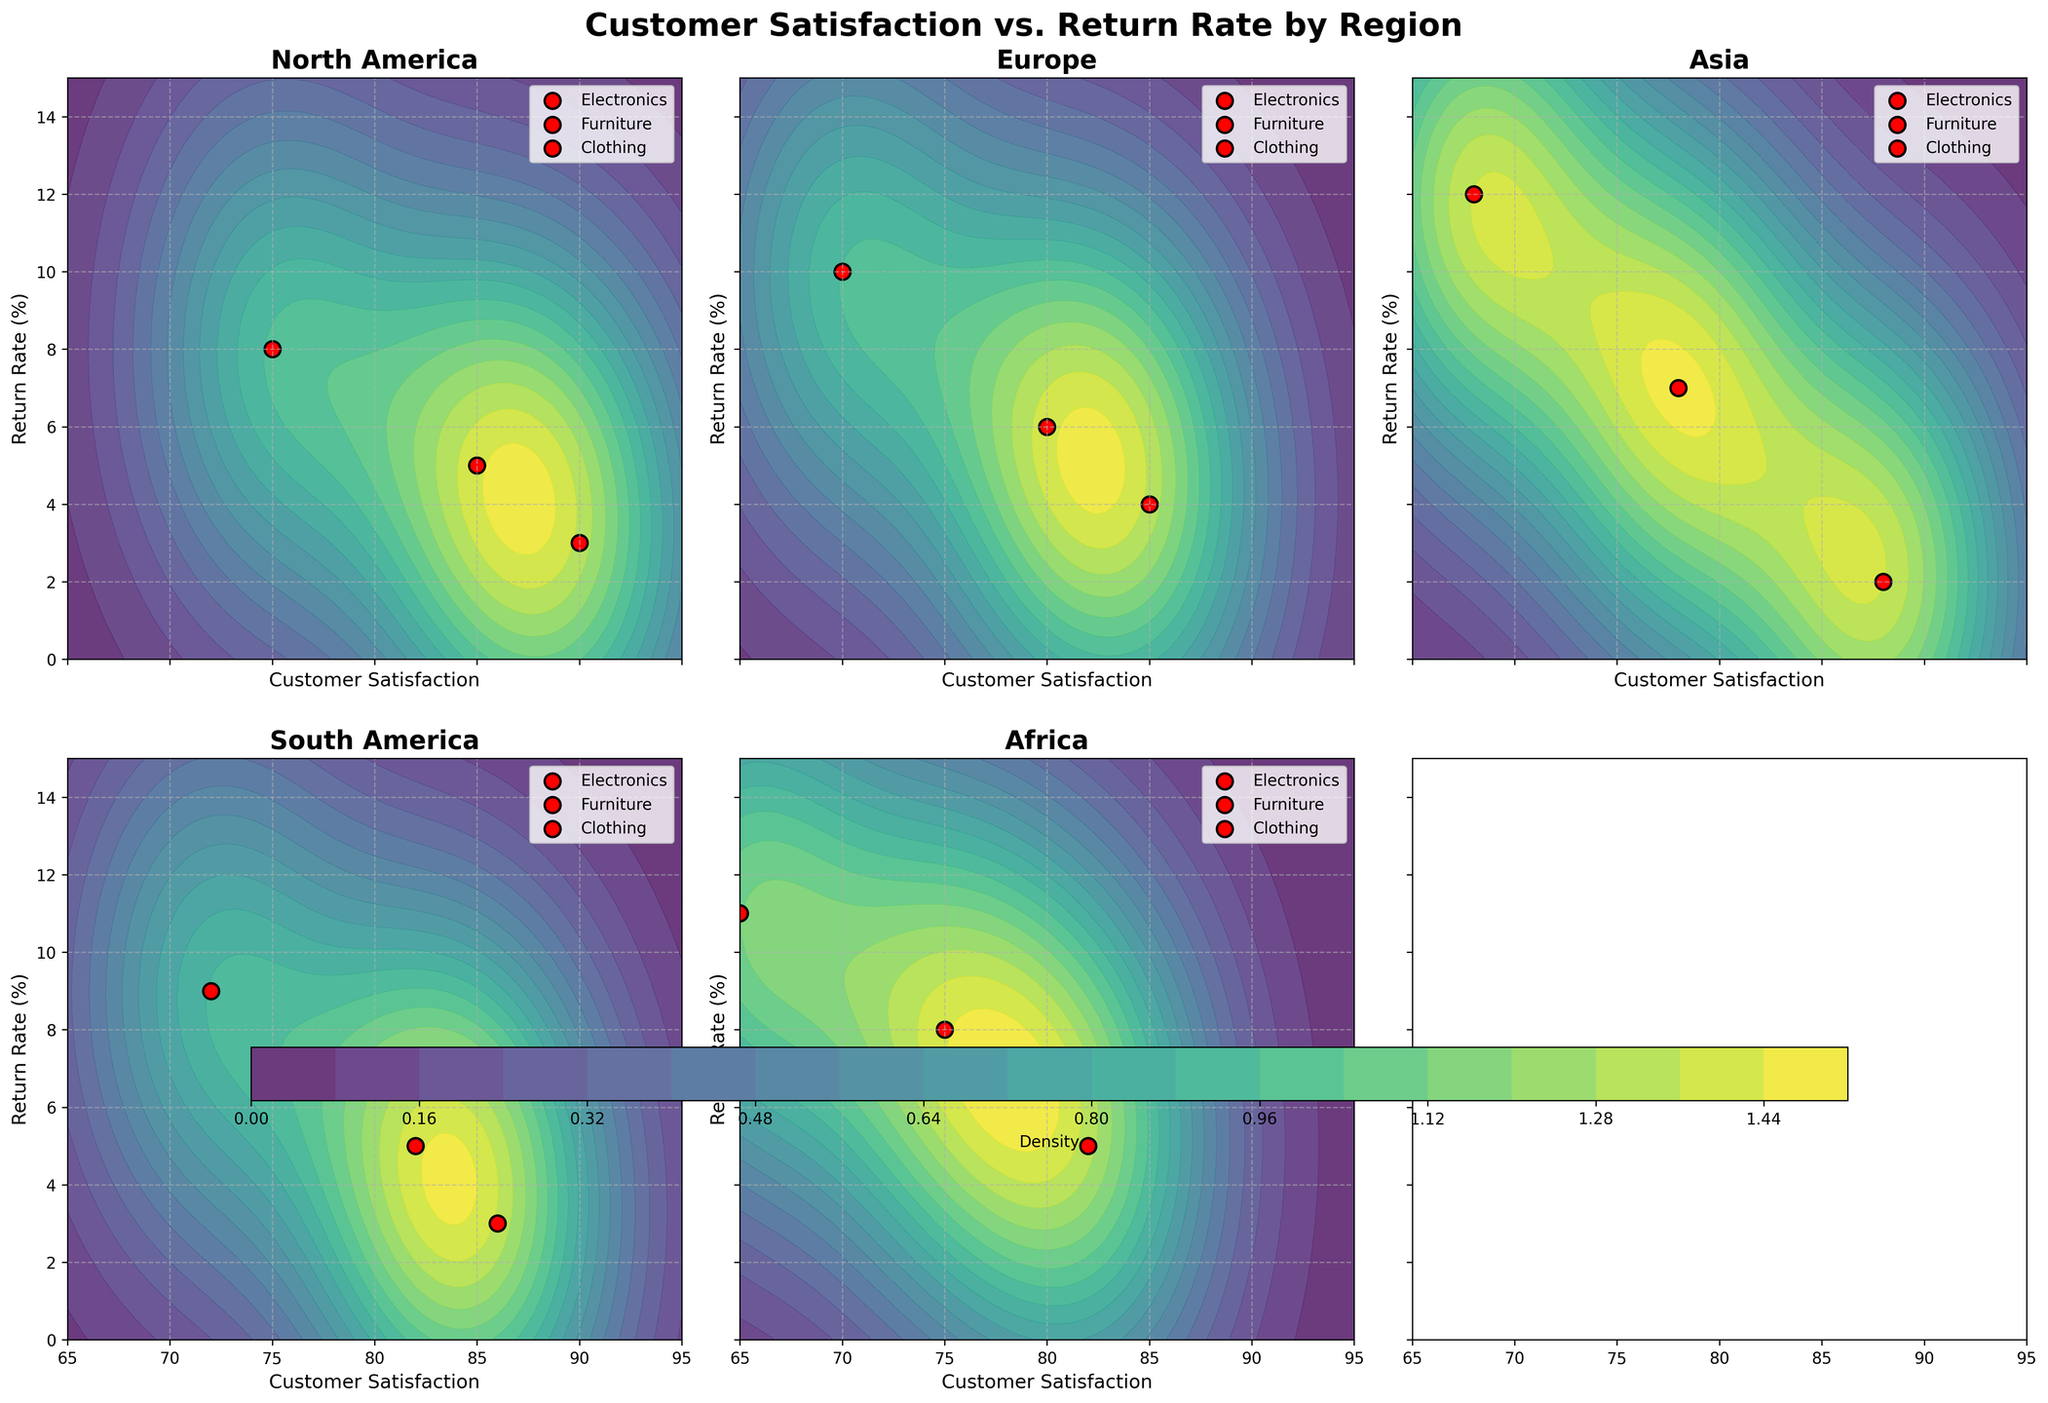What is the title of the figure? The title of the figure is prominently placed at the top of the plot. Based on the data and context provided, it should describe the relationship between Customer Satisfaction and Return Rate across different regions.
Answer: Customer Satisfaction vs. Return Rate by Region How many subplots are there in the figure? The figure is divided into smaller plots for each region. By looking at the number of regions mentioned in the data and the subplot format, you can count the total subplots.
Answer: 6 Which region has the highest customer satisfaction for electronics? Locate the subplot for each region and identify where the point representing electronics is plotted. Compare these satisfaction values across regions.
Answer: North America What is the range of the x-axis in all subplots? Observe the x-axis labels in any of the subplots as they are shared. The min and max values indicate the range of customer satisfaction.
Answer: 65 to 95 Between Europe and Asia, which region has a higher return rate for clothing? In the subplots for Europe and Asia, identify the y-values for the clothing product points and compare the values.
Answer: Asia Which product has the lowest return rate in South America? Look at the subplot for South America and identify the data point with the lowest y-value. Check which product this point represents.
Answer: Furniture In which region does furniture have the highest satisfaction rating? Scan the furniture points across all regional subplots and compare their x-values to find the highest satisfaction rating.
Answer: North America Which two regions have a customer satisfaction rate of around 70 for clothing? Identify the subplots for all regions and check for clothing points that align closely with a satisfaction rating of 70.
Answer: Europe and Asia Is there a region with no product having a return rate above 10%? For each subplot, observe if all the product points have y-values below 10%. Confirm this observation by cross-referencing with multiple subplots.
Answer: South America Which region shows the highest density levels according to the color intensity in the contour plots? Assess the contour plots and compare the intensity of colors within the regions. The highest density is indicated by the most intense (brightest) colors.
Answer: North America 